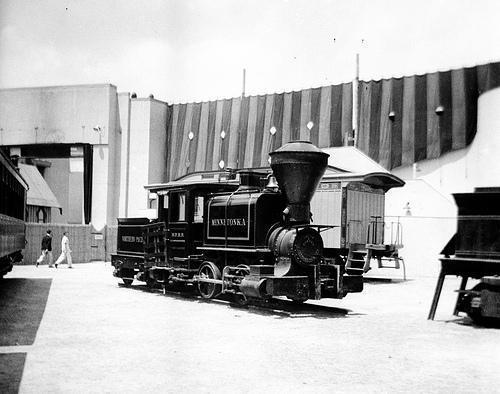How many people are visible?
Give a very brief answer. 2. How many black train engines are shown?
Give a very brief answer. 1. 